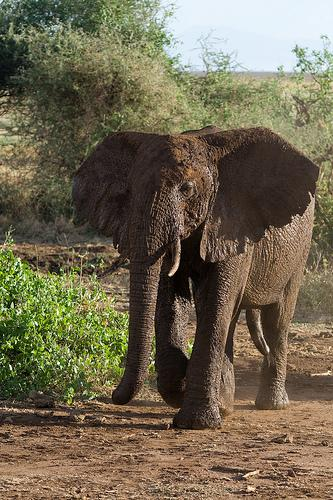Question: what is gray?
Choices:
A. Horse.
B. Elephant.
C. Wolf.
D. Hippopotamus.
Answer with the letter. Answer: B Question: how many elephants are there?
Choices:
A. Two.
B. One.
C. Three.
D. Four.
Answer with the letter. Answer: B Question: who has a trunk?
Choices:
A. Anteater.
B. Aardvark.
C. An elephant.
D. Wooly mammoth.
Answer with the letter. Answer: C Question: what is green?
Choices:
A. Traffic signals.
B. Rose bushes.
C. Lawns.
D. Trees.
Answer with the letter. Answer: D 